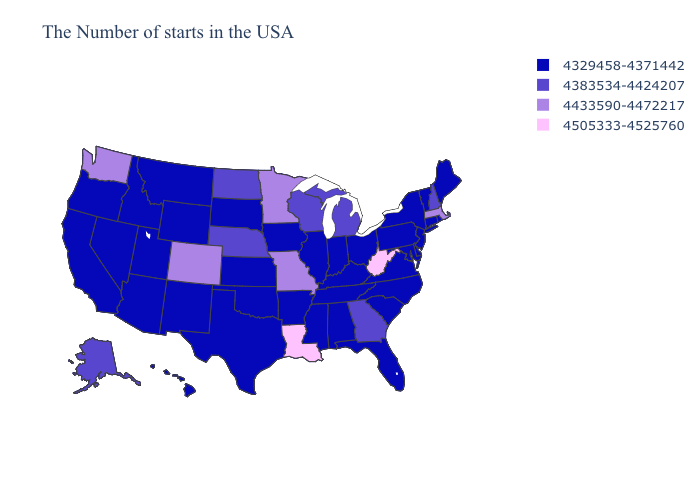Among the states that border New York , which have the highest value?
Answer briefly. Massachusetts. Which states have the highest value in the USA?
Quick response, please. West Virginia, Louisiana. Does Mississippi have a higher value than Texas?
Give a very brief answer. No. Name the states that have a value in the range 4383534-4424207?
Short answer required. New Hampshire, Georgia, Michigan, Wisconsin, Nebraska, North Dakota, Alaska. Does Ohio have the highest value in the MidWest?
Give a very brief answer. No. What is the value of Louisiana?
Keep it brief. 4505333-4525760. Name the states that have a value in the range 4329458-4371442?
Keep it brief. Maine, Rhode Island, Vermont, Connecticut, New York, New Jersey, Delaware, Maryland, Pennsylvania, Virginia, North Carolina, South Carolina, Ohio, Florida, Kentucky, Indiana, Alabama, Tennessee, Illinois, Mississippi, Arkansas, Iowa, Kansas, Oklahoma, Texas, South Dakota, Wyoming, New Mexico, Utah, Montana, Arizona, Idaho, Nevada, California, Oregon, Hawaii. What is the value of New Mexico?
Give a very brief answer. 4329458-4371442. What is the value of Virginia?
Quick response, please. 4329458-4371442. Which states have the lowest value in the Northeast?
Give a very brief answer. Maine, Rhode Island, Vermont, Connecticut, New York, New Jersey, Pennsylvania. Name the states that have a value in the range 4383534-4424207?
Write a very short answer. New Hampshire, Georgia, Michigan, Wisconsin, Nebraska, North Dakota, Alaska. Does the first symbol in the legend represent the smallest category?
Be succinct. Yes. What is the highest value in the USA?
Be succinct. 4505333-4525760. Which states hav the highest value in the Northeast?
Give a very brief answer. Massachusetts. Name the states that have a value in the range 4505333-4525760?
Quick response, please. West Virginia, Louisiana. 